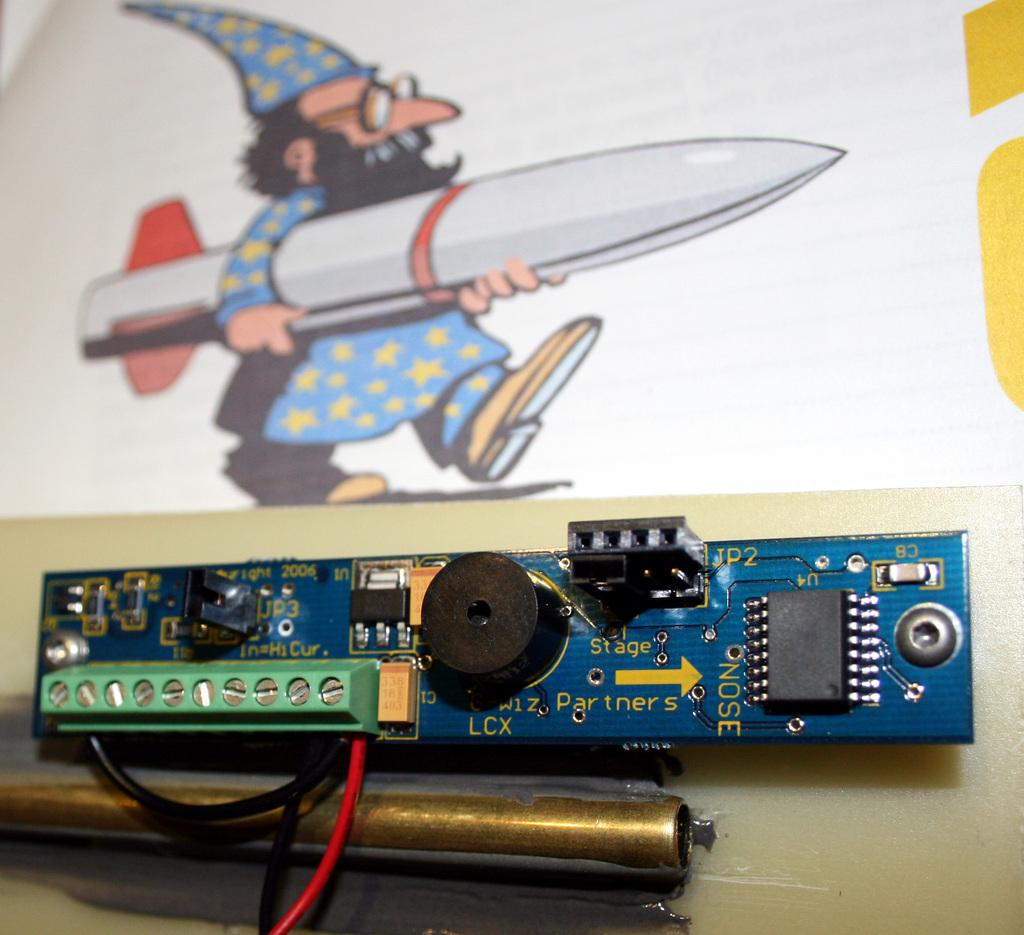What is the main subject of the image? There is an electronic chip in the image. What else can be seen in the background of the image? There is a toy person in the background of the image. What is the toy person wearing? The toy person is wearing a blue dress. What is the toy person holding? The toy person is holding an object. What type of grape is being used as a vase in the image? There is no grape or vase present in the image. How many slices of pie can be seen in the image? There is no pie present in the image. 